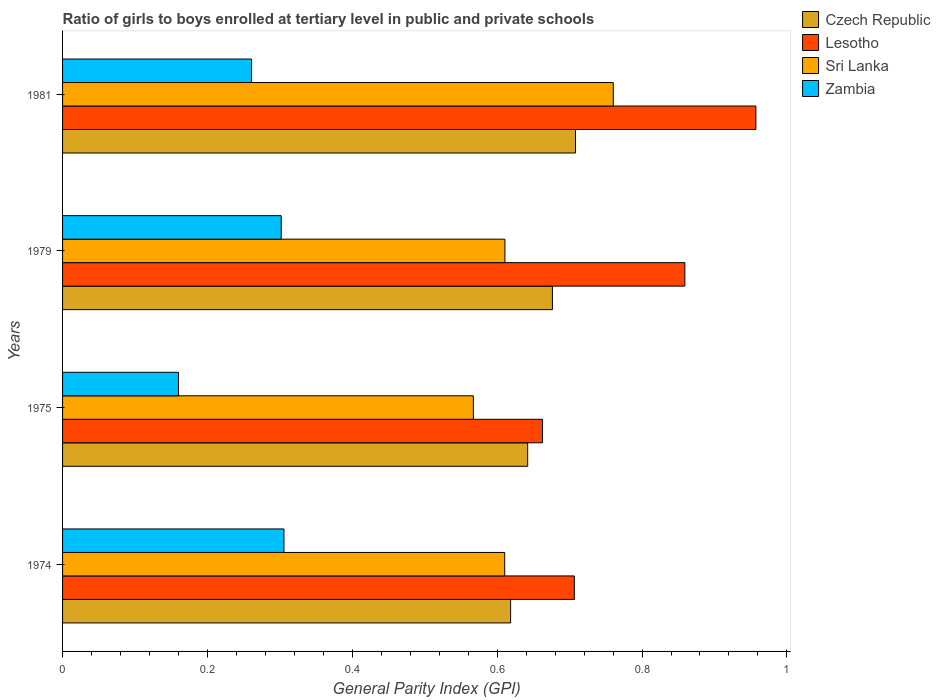Are the number of bars on each tick of the Y-axis equal?
Give a very brief answer. Yes. How many bars are there on the 4th tick from the top?
Keep it short and to the point. 4. What is the general parity index in Czech Republic in 1981?
Your response must be concise. 0.71. Across all years, what is the maximum general parity index in Zambia?
Your response must be concise. 0.31. Across all years, what is the minimum general parity index in Zambia?
Provide a short and direct response. 0.16. In which year was the general parity index in Zambia maximum?
Give a very brief answer. 1974. In which year was the general parity index in Sri Lanka minimum?
Make the answer very short. 1975. What is the total general parity index in Zambia in the graph?
Provide a succinct answer. 1.03. What is the difference between the general parity index in Zambia in 1974 and that in 1979?
Give a very brief answer. 0. What is the difference between the general parity index in Lesotho in 1979 and the general parity index in Czech Republic in 1975?
Offer a terse response. 0.22. What is the average general parity index in Sri Lanka per year?
Offer a very short reply. 0.64. In the year 1981, what is the difference between the general parity index in Zambia and general parity index in Sri Lanka?
Your answer should be compact. -0.5. What is the ratio of the general parity index in Lesotho in 1975 to that in 1981?
Give a very brief answer. 0.69. Is the general parity index in Lesotho in 1975 less than that in 1979?
Your response must be concise. Yes. Is the difference between the general parity index in Zambia in 1975 and 1979 greater than the difference between the general parity index in Sri Lanka in 1975 and 1979?
Your response must be concise. No. What is the difference between the highest and the second highest general parity index in Czech Republic?
Provide a short and direct response. 0.03. What is the difference between the highest and the lowest general parity index in Zambia?
Provide a short and direct response. 0.15. In how many years, is the general parity index in Zambia greater than the average general parity index in Zambia taken over all years?
Make the answer very short. 3. What does the 1st bar from the top in 1981 represents?
Keep it short and to the point. Zambia. What does the 3rd bar from the bottom in 1975 represents?
Ensure brevity in your answer.  Sri Lanka. Is it the case that in every year, the sum of the general parity index in Zambia and general parity index in Sri Lanka is greater than the general parity index in Czech Republic?
Offer a very short reply. Yes. How many bars are there?
Keep it short and to the point. 16. Are all the bars in the graph horizontal?
Give a very brief answer. Yes. Are the values on the major ticks of X-axis written in scientific E-notation?
Offer a terse response. No. Does the graph contain grids?
Make the answer very short. No. Where does the legend appear in the graph?
Offer a terse response. Top right. What is the title of the graph?
Provide a short and direct response. Ratio of girls to boys enrolled at tertiary level in public and private schools. What is the label or title of the X-axis?
Ensure brevity in your answer.  General Parity Index (GPI). What is the label or title of the Y-axis?
Provide a succinct answer. Years. What is the General Parity Index (GPI) of Czech Republic in 1974?
Your answer should be very brief. 0.62. What is the General Parity Index (GPI) of Lesotho in 1974?
Make the answer very short. 0.71. What is the General Parity Index (GPI) of Sri Lanka in 1974?
Make the answer very short. 0.61. What is the General Parity Index (GPI) of Zambia in 1974?
Keep it short and to the point. 0.31. What is the General Parity Index (GPI) in Czech Republic in 1975?
Ensure brevity in your answer.  0.64. What is the General Parity Index (GPI) of Lesotho in 1975?
Ensure brevity in your answer.  0.66. What is the General Parity Index (GPI) of Sri Lanka in 1975?
Make the answer very short. 0.57. What is the General Parity Index (GPI) in Zambia in 1975?
Your answer should be very brief. 0.16. What is the General Parity Index (GPI) of Czech Republic in 1979?
Your response must be concise. 0.68. What is the General Parity Index (GPI) in Lesotho in 1979?
Your answer should be compact. 0.86. What is the General Parity Index (GPI) of Sri Lanka in 1979?
Keep it short and to the point. 0.61. What is the General Parity Index (GPI) of Zambia in 1979?
Make the answer very short. 0.3. What is the General Parity Index (GPI) in Czech Republic in 1981?
Provide a short and direct response. 0.71. What is the General Parity Index (GPI) in Lesotho in 1981?
Your answer should be very brief. 0.96. What is the General Parity Index (GPI) in Sri Lanka in 1981?
Make the answer very short. 0.76. What is the General Parity Index (GPI) of Zambia in 1981?
Your answer should be compact. 0.26. Across all years, what is the maximum General Parity Index (GPI) in Czech Republic?
Offer a very short reply. 0.71. Across all years, what is the maximum General Parity Index (GPI) of Lesotho?
Provide a succinct answer. 0.96. Across all years, what is the maximum General Parity Index (GPI) of Sri Lanka?
Your response must be concise. 0.76. Across all years, what is the maximum General Parity Index (GPI) of Zambia?
Your answer should be compact. 0.31. Across all years, what is the minimum General Parity Index (GPI) in Czech Republic?
Your answer should be compact. 0.62. Across all years, what is the minimum General Parity Index (GPI) of Lesotho?
Your answer should be very brief. 0.66. Across all years, what is the minimum General Parity Index (GPI) in Sri Lanka?
Keep it short and to the point. 0.57. Across all years, what is the minimum General Parity Index (GPI) of Zambia?
Keep it short and to the point. 0.16. What is the total General Parity Index (GPI) of Czech Republic in the graph?
Ensure brevity in your answer.  2.65. What is the total General Parity Index (GPI) of Lesotho in the graph?
Ensure brevity in your answer.  3.19. What is the total General Parity Index (GPI) in Sri Lanka in the graph?
Make the answer very short. 2.55. What is the total General Parity Index (GPI) of Zambia in the graph?
Keep it short and to the point. 1.03. What is the difference between the General Parity Index (GPI) of Czech Republic in 1974 and that in 1975?
Make the answer very short. -0.02. What is the difference between the General Parity Index (GPI) in Lesotho in 1974 and that in 1975?
Your answer should be compact. 0.04. What is the difference between the General Parity Index (GPI) in Sri Lanka in 1974 and that in 1975?
Provide a succinct answer. 0.04. What is the difference between the General Parity Index (GPI) in Zambia in 1974 and that in 1975?
Provide a short and direct response. 0.15. What is the difference between the General Parity Index (GPI) of Czech Republic in 1974 and that in 1979?
Ensure brevity in your answer.  -0.06. What is the difference between the General Parity Index (GPI) in Lesotho in 1974 and that in 1979?
Offer a terse response. -0.15. What is the difference between the General Parity Index (GPI) of Sri Lanka in 1974 and that in 1979?
Make the answer very short. -0. What is the difference between the General Parity Index (GPI) in Zambia in 1974 and that in 1979?
Make the answer very short. 0. What is the difference between the General Parity Index (GPI) of Czech Republic in 1974 and that in 1981?
Your response must be concise. -0.09. What is the difference between the General Parity Index (GPI) in Lesotho in 1974 and that in 1981?
Offer a terse response. -0.25. What is the difference between the General Parity Index (GPI) in Sri Lanka in 1974 and that in 1981?
Give a very brief answer. -0.15. What is the difference between the General Parity Index (GPI) in Zambia in 1974 and that in 1981?
Provide a succinct answer. 0.04. What is the difference between the General Parity Index (GPI) of Czech Republic in 1975 and that in 1979?
Your answer should be very brief. -0.03. What is the difference between the General Parity Index (GPI) of Lesotho in 1975 and that in 1979?
Make the answer very short. -0.2. What is the difference between the General Parity Index (GPI) in Sri Lanka in 1975 and that in 1979?
Ensure brevity in your answer.  -0.04. What is the difference between the General Parity Index (GPI) of Zambia in 1975 and that in 1979?
Give a very brief answer. -0.14. What is the difference between the General Parity Index (GPI) in Czech Republic in 1975 and that in 1981?
Give a very brief answer. -0.07. What is the difference between the General Parity Index (GPI) in Lesotho in 1975 and that in 1981?
Provide a succinct answer. -0.29. What is the difference between the General Parity Index (GPI) of Sri Lanka in 1975 and that in 1981?
Your answer should be compact. -0.19. What is the difference between the General Parity Index (GPI) of Zambia in 1975 and that in 1981?
Make the answer very short. -0.1. What is the difference between the General Parity Index (GPI) of Czech Republic in 1979 and that in 1981?
Offer a very short reply. -0.03. What is the difference between the General Parity Index (GPI) of Lesotho in 1979 and that in 1981?
Make the answer very short. -0.1. What is the difference between the General Parity Index (GPI) of Sri Lanka in 1979 and that in 1981?
Your response must be concise. -0.15. What is the difference between the General Parity Index (GPI) in Zambia in 1979 and that in 1981?
Keep it short and to the point. 0.04. What is the difference between the General Parity Index (GPI) of Czech Republic in 1974 and the General Parity Index (GPI) of Lesotho in 1975?
Your answer should be compact. -0.04. What is the difference between the General Parity Index (GPI) of Czech Republic in 1974 and the General Parity Index (GPI) of Sri Lanka in 1975?
Your answer should be compact. 0.05. What is the difference between the General Parity Index (GPI) of Czech Republic in 1974 and the General Parity Index (GPI) of Zambia in 1975?
Keep it short and to the point. 0.46. What is the difference between the General Parity Index (GPI) of Lesotho in 1974 and the General Parity Index (GPI) of Sri Lanka in 1975?
Provide a short and direct response. 0.14. What is the difference between the General Parity Index (GPI) in Lesotho in 1974 and the General Parity Index (GPI) in Zambia in 1975?
Offer a terse response. 0.55. What is the difference between the General Parity Index (GPI) in Sri Lanka in 1974 and the General Parity Index (GPI) in Zambia in 1975?
Your answer should be compact. 0.45. What is the difference between the General Parity Index (GPI) in Czech Republic in 1974 and the General Parity Index (GPI) in Lesotho in 1979?
Your answer should be very brief. -0.24. What is the difference between the General Parity Index (GPI) of Czech Republic in 1974 and the General Parity Index (GPI) of Sri Lanka in 1979?
Your answer should be very brief. 0.01. What is the difference between the General Parity Index (GPI) of Czech Republic in 1974 and the General Parity Index (GPI) of Zambia in 1979?
Your response must be concise. 0.32. What is the difference between the General Parity Index (GPI) in Lesotho in 1974 and the General Parity Index (GPI) in Sri Lanka in 1979?
Make the answer very short. 0.1. What is the difference between the General Parity Index (GPI) of Lesotho in 1974 and the General Parity Index (GPI) of Zambia in 1979?
Give a very brief answer. 0.4. What is the difference between the General Parity Index (GPI) in Sri Lanka in 1974 and the General Parity Index (GPI) in Zambia in 1979?
Offer a very short reply. 0.31. What is the difference between the General Parity Index (GPI) in Czech Republic in 1974 and the General Parity Index (GPI) in Lesotho in 1981?
Provide a succinct answer. -0.34. What is the difference between the General Parity Index (GPI) of Czech Republic in 1974 and the General Parity Index (GPI) of Sri Lanka in 1981?
Provide a succinct answer. -0.14. What is the difference between the General Parity Index (GPI) of Czech Republic in 1974 and the General Parity Index (GPI) of Zambia in 1981?
Provide a short and direct response. 0.36. What is the difference between the General Parity Index (GPI) of Lesotho in 1974 and the General Parity Index (GPI) of Sri Lanka in 1981?
Your answer should be compact. -0.05. What is the difference between the General Parity Index (GPI) of Lesotho in 1974 and the General Parity Index (GPI) of Zambia in 1981?
Keep it short and to the point. 0.45. What is the difference between the General Parity Index (GPI) in Sri Lanka in 1974 and the General Parity Index (GPI) in Zambia in 1981?
Offer a very short reply. 0.35. What is the difference between the General Parity Index (GPI) in Czech Republic in 1975 and the General Parity Index (GPI) in Lesotho in 1979?
Your answer should be compact. -0.22. What is the difference between the General Parity Index (GPI) in Czech Republic in 1975 and the General Parity Index (GPI) in Sri Lanka in 1979?
Your answer should be compact. 0.03. What is the difference between the General Parity Index (GPI) in Czech Republic in 1975 and the General Parity Index (GPI) in Zambia in 1979?
Make the answer very short. 0.34. What is the difference between the General Parity Index (GPI) in Lesotho in 1975 and the General Parity Index (GPI) in Sri Lanka in 1979?
Offer a terse response. 0.05. What is the difference between the General Parity Index (GPI) of Lesotho in 1975 and the General Parity Index (GPI) of Zambia in 1979?
Your answer should be very brief. 0.36. What is the difference between the General Parity Index (GPI) of Sri Lanka in 1975 and the General Parity Index (GPI) of Zambia in 1979?
Make the answer very short. 0.27. What is the difference between the General Parity Index (GPI) in Czech Republic in 1975 and the General Parity Index (GPI) in Lesotho in 1981?
Your response must be concise. -0.32. What is the difference between the General Parity Index (GPI) of Czech Republic in 1975 and the General Parity Index (GPI) of Sri Lanka in 1981?
Offer a very short reply. -0.12. What is the difference between the General Parity Index (GPI) in Czech Republic in 1975 and the General Parity Index (GPI) in Zambia in 1981?
Keep it short and to the point. 0.38. What is the difference between the General Parity Index (GPI) of Lesotho in 1975 and the General Parity Index (GPI) of Sri Lanka in 1981?
Offer a terse response. -0.1. What is the difference between the General Parity Index (GPI) in Lesotho in 1975 and the General Parity Index (GPI) in Zambia in 1981?
Provide a succinct answer. 0.4. What is the difference between the General Parity Index (GPI) of Sri Lanka in 1975 and the General Parity Index (GPI) of Zambia in 1981?
Offer a very short reply. 0.31. What is the difference between the General Parity Index (GPI) in Czech Republic in 1979 and the General Parity Index (GPI) in Lesotho in 1981?
Offer a very short reply. -0.28. What is the difference between the General Parity Index (GPI) in Czech Republic in 1979 and the General Parity Index (GPI) in Sri Lanka in 1981?
Make the answer very short. -0.08. What is the difference between the General Parity Index (GPI) of Czech Republic in 1979 and the General Parity Index (GPI) of Zambia in 1981?
Ensure brevity in your answer.  0.42. What is the difference between the General Parity Index (GPI) in Lesotho in 1979 and the General Parity Index (GPI) in Sri Lanka in 1981?
Ensure brevity in your answer.  0.1. What is the difference between the General Parity Index (GPI) of Lesotho in 1979 and the General Parity Index (GPI) of Zambia in 1981?
Ensure brevity in your answer.  0.6. What is the difference between the General Parity Index (GPI) in Sri Lanka in 1979 and the General Parity Index (GPI) in Zambia in 1981?
Make the answer very short. 0.35. What is the average General Parity Index (GPI) in Czech Republic per year?
Your answer should be compact. 0.66. What is the average General Parity Index (GPI) in Lesotho per year?
Ensure brevity in your answer.  0.8. What is the average General Parity Index (GPI) of Sri Lanka per year?
Ensure brevity in your answer.  0.64. What is the average General Parity Index (GPI) in Zambia per year?
Ensure brevity in your answer.  0.26. In the year 1974, what is the difference between the General Parity Index (GPI) of Czech Republic and General Parity Index (GPI) of Lesotho?
Ensure brevity in your answer.  -0.09. In the year 1974, what is the difference between the General Parity Index (GPI) of Czech Republic and General Parity Index (GPI) of Sri Lanka?
Provide a succinct answer. 0.01. In the year 1974, what is the difference between the General Parity Index (GPI) in Czech Republic and General Parity Index (GPI) in Zambia?
Make the answer very short. 0.31. In the year 1974, what is the difference between the General Parity Index (GPI) of Lesotho and General Parity Index (GPI) of Sri Lanka?
Provide a short and direct response. 0.1. In the year 1974, what is the difference between the General Parity Index (GPI) in Lesotho and General Parity Index (GPI) in Zambia?
Make the answer very short. 0.4. In the year 1974, what is the difference between the General Parity Index (GPI) of Sri Lanka and General Parity Index (GPI) of Zambia?
Give a very brief answer. 0.3. In the year 1975, what is the difference between the General Parity Index (GPI) of Czech Republic and General Parity Index (GPI) of Lesotho?
Your answer should be compact. -0.02. In the year 1975, what is the difference between the General Parity Index (GPI) in Czech Republic and General Parity Index (GPI) in Sri Lanka?
Your response must be concise. 0.07. In the year 1975, what is the difference between the General Parity Index (GPI) of Czech Republic and General Parity Index (GPI) of Zambia?
Offer a terse response. 0.48. In the year 1975, what is the difference between the General Parity Index (GPI) of Lesotho and General Parity Index (GPI) of Sri Lanka?
Give a very brief answer. 0.1. In the year 1975, what is the difference between the General Parity Index (GPI) of Lesotho and General Parity Index (GPI) of Zambia?
Ensure brevity in your answer.  0.5. In the year 1975, what is the difference between the General Parity Index (GPI) in Sri Lanka and General Parity Index (GPI) in Zambia?
Provide a short and direct response. 0.41. In the year 1979, what is the difference between the General Parity Index (GPI) in Czech Republic and General Parity Index (GPI) in Lesotho?
Make the answer very short. -0.18. In the year 1979, what is the difference between the General Parity Index (GPI) of Czech Republic and General Parity Index (GPI) of Sri Lanka?
Ensure brevity in your answer.  0.07. In the year 1979, what is the difference between the General Parity Index (GPI) in Czech Republic and General Parity Index (GPI) in Zambia?
Your response must be concise. 0.37. In the year 1979, what is the difference between the General Parity Index (GPI) of Lesotho and General Parity Index (GPI) of Sri Lanka?
Ensure brevity in your answer.  0.25. In the year 1979, what is the difference between the General Parity Index (GPI) in Lesotho and General Parity Index (GPI) in Zambia?
Offer a very short reply. 0.56. In the year 1979, what is the difference between the General Parity Index (GPI) of Sri Lanka and General Parity Index (GPI) of Zambia?
Offer a very short reply. 0.31. In the year 1981, what is the difference between the General Parity Index (GPI) in Czech Republic and General Parity Index (GPI) in Lesotho?
Provide a succinct answer. -0.25. In the year 1981, what is the difference between the General Parity Index (GPI) in Czech Republic and General Parity Index (GPI) in Sri Lanka?
Offer a very short reply. -0.05. In the year 1981, what is the difference between the General Parity Index (GPI) of Czech Republic and General Parity Index (GPI) of Zambia?
Keep it short and to the point. 0.45. In the year 1981, what is the difference between the General Parity Index (GPI) in Lesotho and General Parity Index (GPI) in Sri Lanka?
Keep it short and to the point. 0.2. In the year 1981, what is the difference between the General Parity Index (GPI) in Lesotho and General Parity Index (GPI) in Zambia?
Provide a short and direct response. 0.7. In the year 1981, what is the difference between the General Parity Index (GPI) in Sri Lanka and General Parity Index (GPI) in Zambia?
Give a very brief answer. 0.5. What is the ratio of the General Parity Index (GPI) of Czech Republic in 1974 to that in 1975?
Keep it short and to the point. 0.96. What is the ratio of the General Parity Index (GPI) of Lesotho in 1974 to that in 1975?
Your answer should be compact. 1.07. What is the ratio of the General Parity Index (GPI) of Sri Lanka in 1974 to that in 1975?
Your answer should be compact. 1.08. What is the ratio of the General Parity Index (GPI) in Zambia in 1974 to that in 1975?
Your answer should be very brief. 1.91. What is the ratio of the General Parity Index (GPI) in Czech Republic in 1974 to that in 1979?
Make the answer very short. 0.91. What is the ratio of the General Parity Index (GPI) of Lesotho in 1974 to that in 1979?
Make the answer very short. 0.82. What is the ratio of the General Parity Index (GPI) of Sri Lanka in 1974 to that in 1979?
Offer a very short reply. 1. What is the ratio of the General Parity Index (GPI) of Zambia in 1974 to that in 1979?
Your answer should be very brief. 1.01. What is the ratio of the General Parity Index (GPI) in Czech Republic in 1974 to that in 1981?
Offer a terse response. 0.87. What is the ratio of the General Parity Index (GPI) of Lesotho in 1974 to that in 1981?
Your answer should be very brief. 0.74. What is the ratio of the General Parity Index (GPI) of Sri Lanka in 1974 to that in 1981?
Your answer should be compact. 0.8. What is the ratio of the General Parity Index (GPI) in Zambia in 1974 to that in 1981?
Provide a short and direct response. 1.17. What is the ratio of the General Parity Index (GPI) in Czech Republic in 1975 to that in 1979?
Offer a very short reply. 0.95. What is the ratio of the General Parity Index (GPI) in Lesotho in 1975 to that in 1979?
Give a very brief answer. 0.77. What is the ratio of the General Parity Index (GPI) of Sri Lanka in 1975 to that in 1979?
Offer a terse response. 0.93. What is the ratio of the General Parity Index (GPI) of Zambia in 1975 to that in 1979?
Your response must be concise. 0.53. What is the ratio of the General Parity Index (GPI) in Czech Republic in 1975 to that in 1981?
Keep it short and to the point. 0.91. What is the ratio of the General Parity Index (GPI) in Lesotho in 1975 to that in 1981?
Your response must be concise. 0.69. What is the ratio of the General Parity Index (GPI) in Sri Lanka in 1975 to that in 1981?
Give a very brief answer. 0.75. What is the ratio of the General Parity Index (GPI) of Zambia in 1975 to that in 1981?
Keep it short and to the point. 0.61. What is the ratio of the General Parity Index (GPI) of Czech Republic in 1979 to that in 1981?
Offer a very short reply. 0.95. What is the ratio of the General Parity Index (GPI) in Lesotho in 1979 to that in 1981?
Offer a terse response. 0.9. What is the ratio of the General Parity Index (GPI) of Sri Lanka in 1979 to that in 1981?
Give a very brief answer. 0.8. What is the ratio of the General Parity Index (GPI) of Zambia in 1979 to that in 1981?
Offer a terse response. 1.16. What is the difference between the highest and the second highest General Parity Index (GPI) in Czech Republic?
Keep it short and to the point. 0.03. What is the difference between the highest and the second highest General Parity Index (GPI) in Lesotho?
Make the answer very short. 0.1. What is the difference between the highest and the second highest General Parity Index (GPI) of Sri Lanka?
Provide a short and direct response. 0.15. What is the difference between the highest and the second highest General Parity Index (GPI) of Zambia?
Provide a succinct answer. 0. What is the difference between the highest and the lowest General Parity Index (GPI) of Czech Republic?
Offer a terse response. 0.09. What is the difference between the highest and the lowest General Parity Index (GPI) of Lesotho?
Your answer should be very brief. 0.29. What is the difference between the highest and the lowest General Parity Index (GPI) of Sri Lanka?
Offer a very short reply. 0.19. What is the difference between the highest and the lowest General Parity Index (GPI) in Zambia?
Make the answer very short. 0.15. 